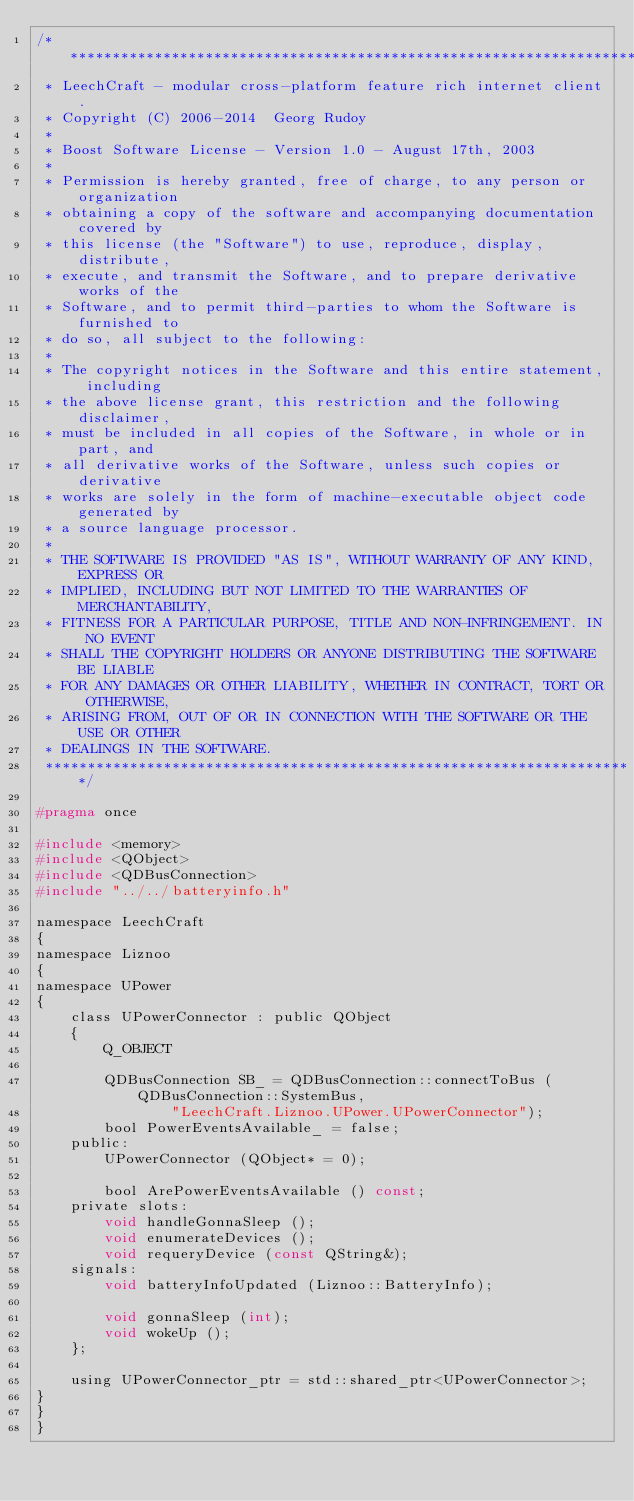Convert code to text. <code><loc_0><loc_0><loc_500><loc_500><_C_>/**********************************************************************
 * LeechCraft - modular cross-platform feature rich internet client.
 * Copyright (C) 2006-2014  Georg Rudoy
 *
 * Boost Software License - Version 1.0 - August 17th, 2003
 *
 * Permission is hereby granted, free of charge, to any person or organization
 * obtaining a copy of the software and accompanying documentation covered by
 * this license (the "Software") to use, reproduce, display, distribute,
 * execute, and transmit the Software, and to prepare derivative works of the
 * Software, and to permit third-parties to whom the Software is furnished to
 * do so, all subject to the following:
 *
 * The copyright notices in the Software and this entire statement, including
 * the above license grant, this restriction and the following disclaimer,
 * must be included in all copies of the Software, in whole or in part, and
 * all derivative works of the Software, unless such copies or derivative
 * works are solely in the form of machine-executable object code generated by
 * a source language processor.
 *
 * THE SOFTWARE IS PROVIDED "AS IS", WITHOUT WARRANTY OF ANY KIND, EXPRESS OR
 * IMPLIED, INCLUDING BUT NOT LIMITED TO THE WARRANTIES OF MERCHANTABILITY,
 * FITNESS FOR A PARTICULAR PURPOSE, TITLE AND NON-INFRINGEMENT. IN NO EVENT
 * SHALL THE COPYRIGHT HOLDERS OR ANYONE DISTRIBUTING THE SOFTWARE BE LIABLE
 * FOR ANY DAMAGES OR OTHER LIABILITY, WHETHER IN CONTRACT, TORT OR OTHERWISE,
 * ARISING FROM, OUT OF OR IN CONNECTION WITH THE SOFTWARE OR THE USE OR OTHER
 * DEALINGS IN THE SOFTWARE.
 **********************************************************************/

#pragma once

#include <memory>
#include <QObject>
#include <QDBusConnection>
#include "../../batteryinfo.h"

namespace LeechCraft
{
namespace Liznoo
{
namespace UPower
{
	class UPowerConnector : public QObject
	{
		Q_OBJECT

		QDBusConnection SB_ = QDBusConnection::connectToBus (QDBusConnection::SystemBus,
				"LeechCraft.Liznoo.UPower.UPowerConnector");
		bool PowerEventsAvailable_ = false;
	public:
		UPowerConnector (QObject* = 0);

		bool ArePowerEventsAvailable () const;
	private slots:
		void handleGonnaSleep ();
		void enumerateDevices ();
		void requeryDevice (const QString&);
	signals:
		void batteryInfoUpdated (Liznoo::BatteryInfo);

		void gonnaSleep (int);
		void wokeUp ();
	};

	using UPowerConnector_ptr = std::shared_ptr<UPowerConnector>;
}
}
}
</code> 